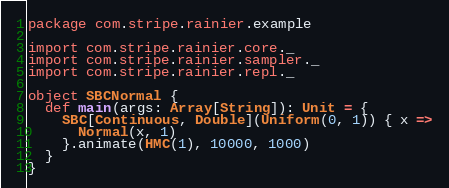Convert code to text. <code><loc_0><loc_0><loc_500><loc_500><_Scala_>package com.stripe.rainier.example

import com.stripe.rainier.core._
import com.stripe.rainier.sampler._
import com.stripe.rainier.repl._

object SBCNormal {
  def main(args: Array[String]): Unit = {
    SBC[Continuous, Double](Uniform(0, 1)) { x =>
      Normal(x, 1)
    }.animate(HMC(1), 10000, 1000)
  }
}
</code> 